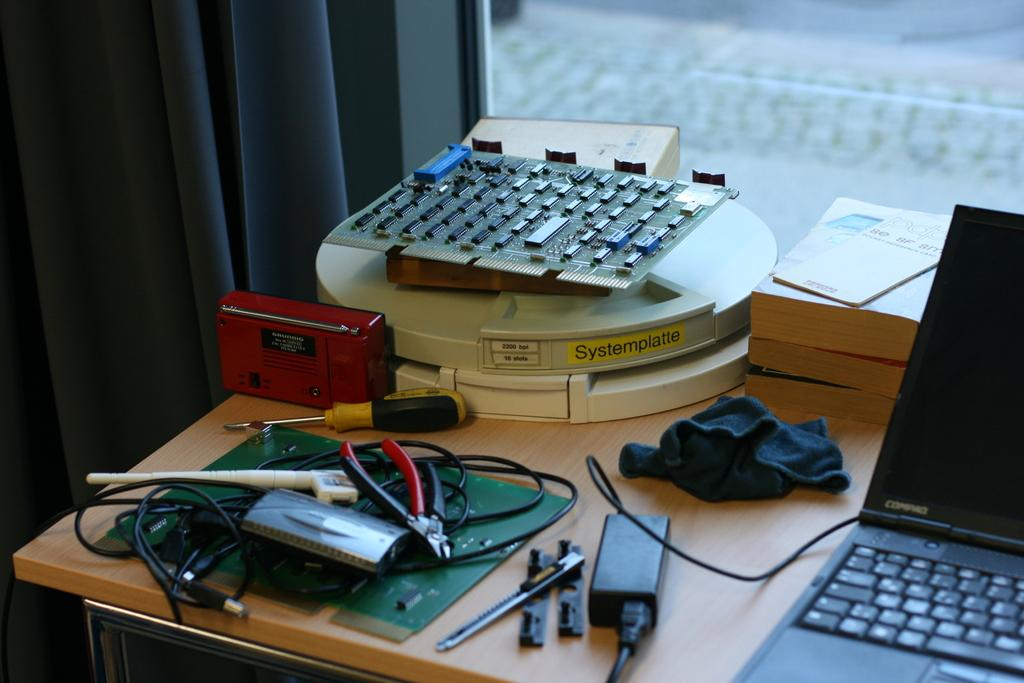What can be seen in the background of the image? There is a window in the background, and curtains are associated with the window. What is on the table in the image? A laptop, a cloth, an adapter, a screwdriver, a cutting plier, and a red FM radio are on the table. What type of objects are present on the table? There are tools on the table, including a screwdriver and a cutting plier. What else is visible in the image besides the table and its contents? There is a paper in the image. How many apples are on the table in the image? There are no apples present in the image. What is the mother doing in the image? There is no mother or any person present in the image. Can you see the moon in the image? The moon is not visible in the image. 